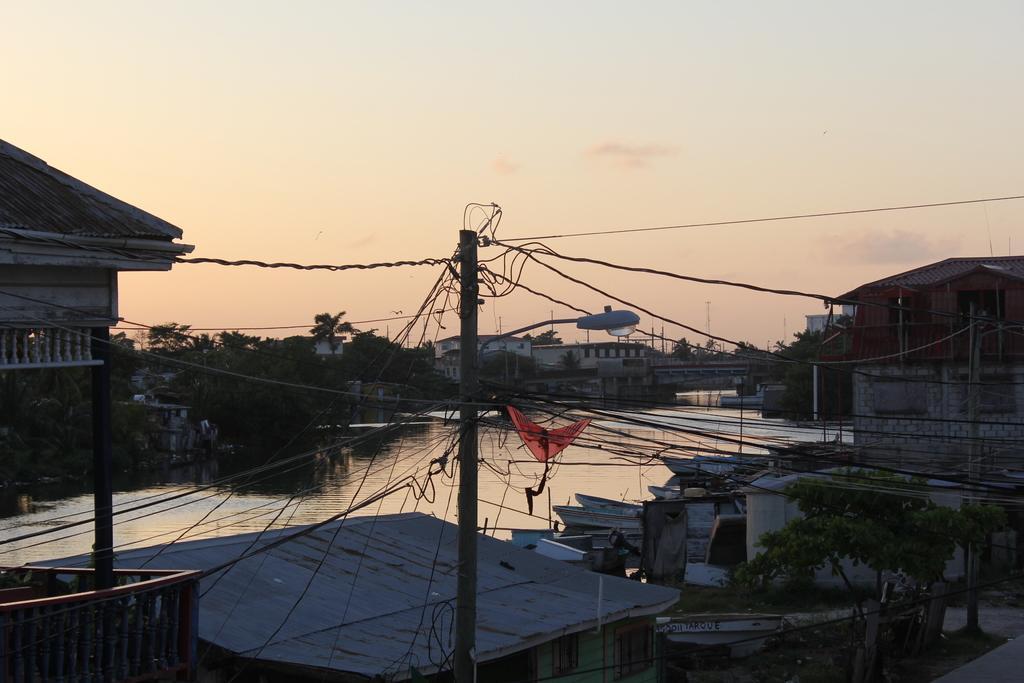Describe this image in one or two sentences. At the bottom of this image, there are buildings having roofs, trees, poles which are having electric cables on the ground. Beside them, there are boats parked on the water of a lake. In the background, there are buildings, trees, a bridge built on the water and there are clouds in the sky. 